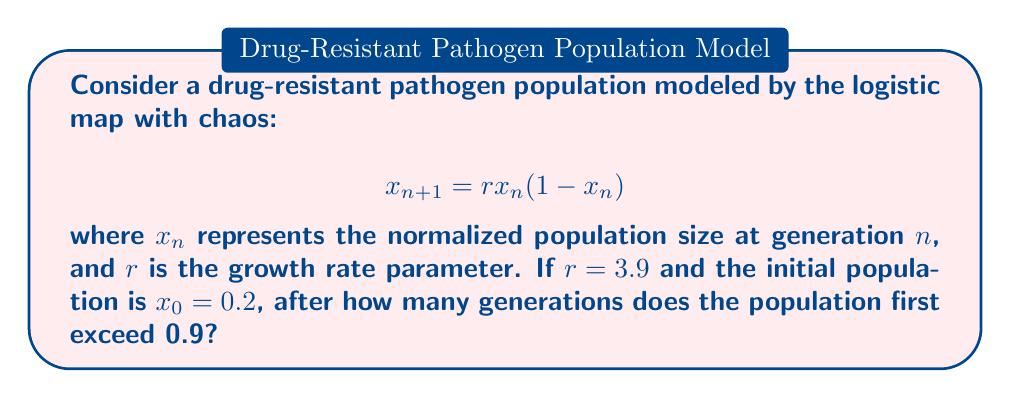What is the answer to this math problem? To solve this problem, we need to iterate the logistic map equation and track the population size:

1) Start with $x_0 = 0.2$ and $r = 3.9$

2) Iterate the equation:
   $x_1 = 3.9 \cdot 0.2 \cdot (1-0.2) = 0.624$
   $x_2 = 3.9 \cdot 0.624 \cdot (1-0.624) = 0.915024$

3) We see that $x_2 > 0.9$, so the population first exceeds 0.9 after 2 generations.

Note: This simple model demonstrates chaotic behavior for $r > 3.57$. In reality, pathogen populations would be influenced by many more factors, but this model can provide insights into potential erratic behavior in drug-resistant populations.
Answer: 2 generations 